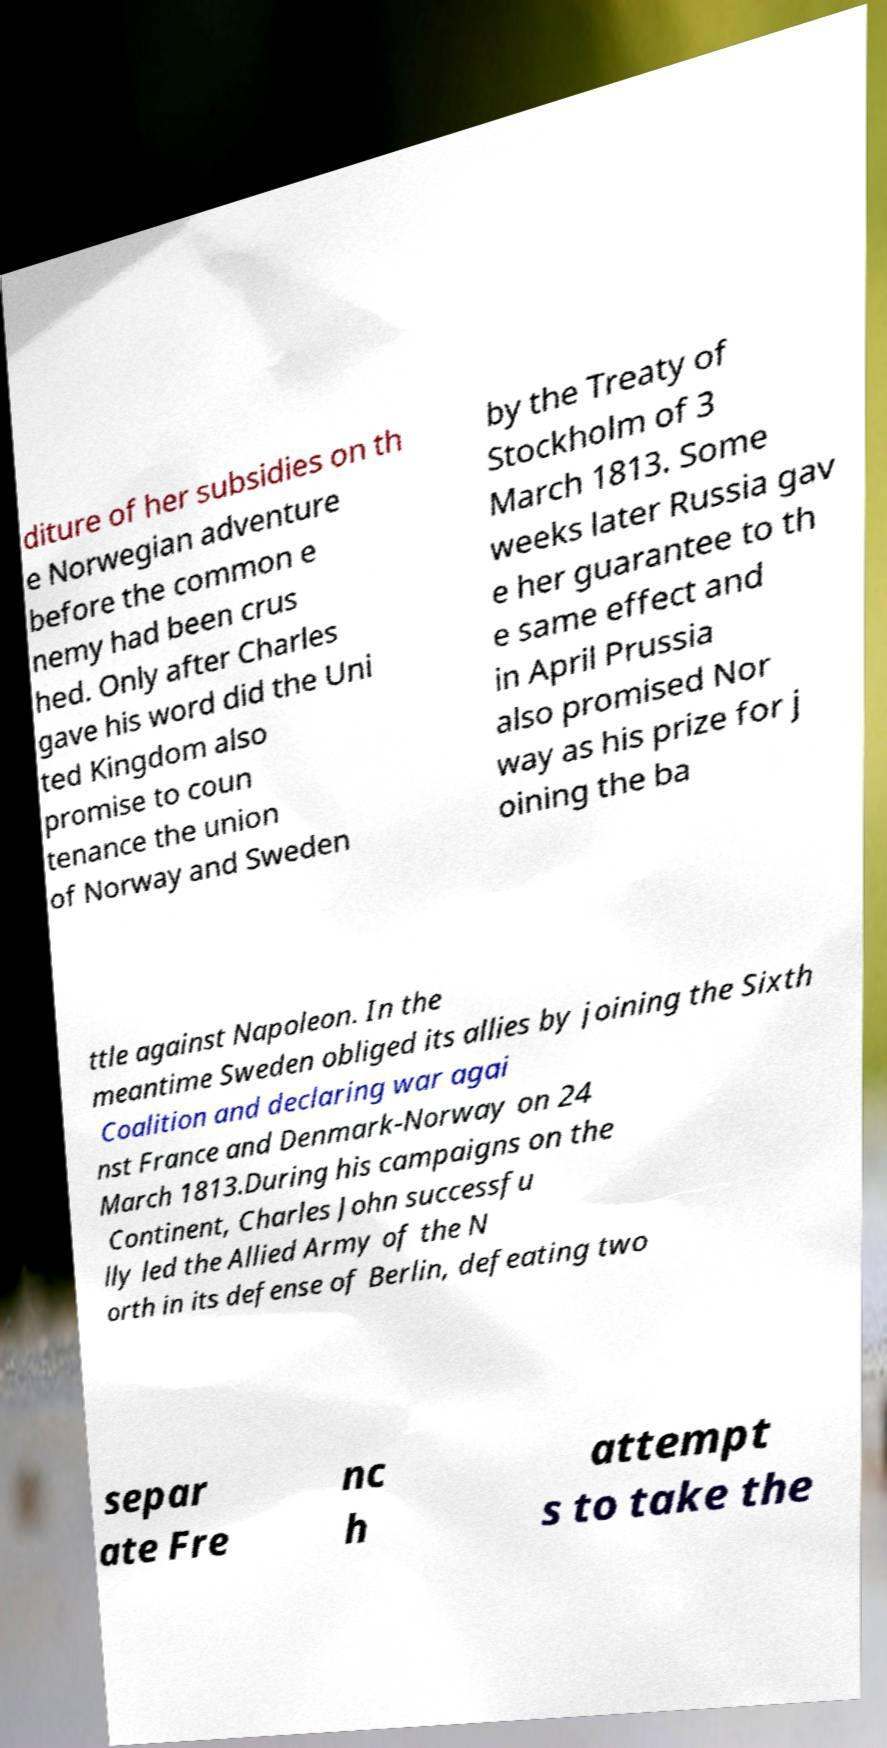Can you accurately transcribe the text from the provided image for me? diture of her subsidies on th e Norwegian adventure before the common e nemy had been crus hed. Only after Charles gave his word did the Uni ted Kingdom also promise to coun tenance the union of Norway and Sweden by the Treaty of Stockholm of 3 March 1813. Some weeks later Russia gav e her guarantee to th e same effect and in April Prussia also promised Nor way as his prize for j oining the ba ttle against Napoleon. In the meantime Sweden obliged its allies by joining the Sixth Coalition and declaring war agai nst France and Denmark-Norway on 24 March 1813.During his campaigns on the Continent, Charles John successfu lly led the Allied Army of the N orth in its defense of Berlin, defeating two separ ate Fre nc h attempt s to take the 